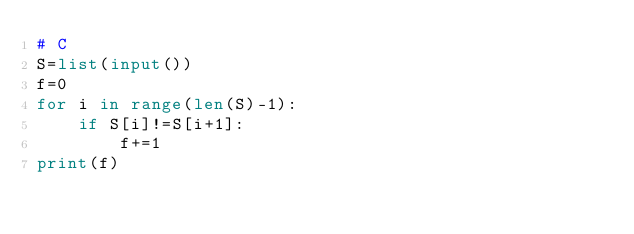Convert code to text. <code><loc_0><loc_0><loc_500><loc_500><_Python_># C
S=list(input())
f=0
for i in range(len(S)-1):
    if S[i]!=S[i+1]:
        f+=1
print(f)</code> 